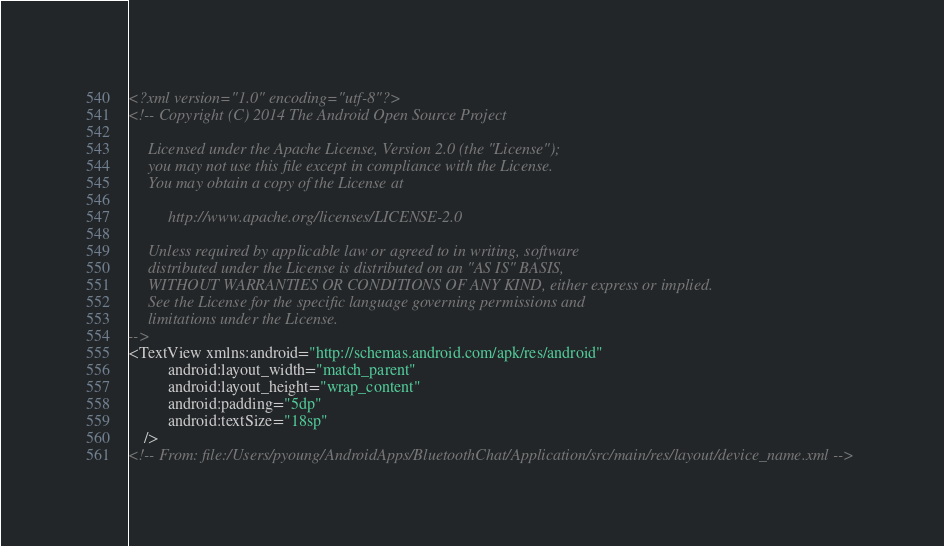<code> <loc_0><loc_0><loc_500><loc_500><_XML_><?xml version="1.0" encoding="utf-8"?>
<!-- Copyright (C) 2014 The Android Open Source Project

     Licensed under the Apache License, Version 2.0 (the "License");
     you may not use this file except in compliance with the License.
     You may obtain a copy of the License at

          http://www.apache.org/licenses/LICENSE-2.0

     Unless required by applicable law or agreed to in writing, software
     distributed under the License is distributed on an "AS IS" BASIS,
     WITHOUT WARRANTIES OR CONDITIONS OF ANY KIND, either express or implied.
     See the License for the specific language governing permissions and
     limitations under the License.
-->
<TextView xmlns:android="http://schemas.android.com/apk/res/android"
          android:layout_width="match_parent"
          android:layout_height="wrap_content"
          android:padding="5dp"
          android:textSize="18sp"
    />
<!-- From: file:/Users/pyoung/AndroidApps/BluetoothChat/Application/src/main/res/layout/device_name.xml --></code> 